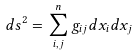<formula> <loc_0><loc_0><loc_500><loc_500>d s ^ { 2 } = \sum _ { i , j } ^ { n } g _ { i j } d x _ { i } d x _ { j }</formula> 